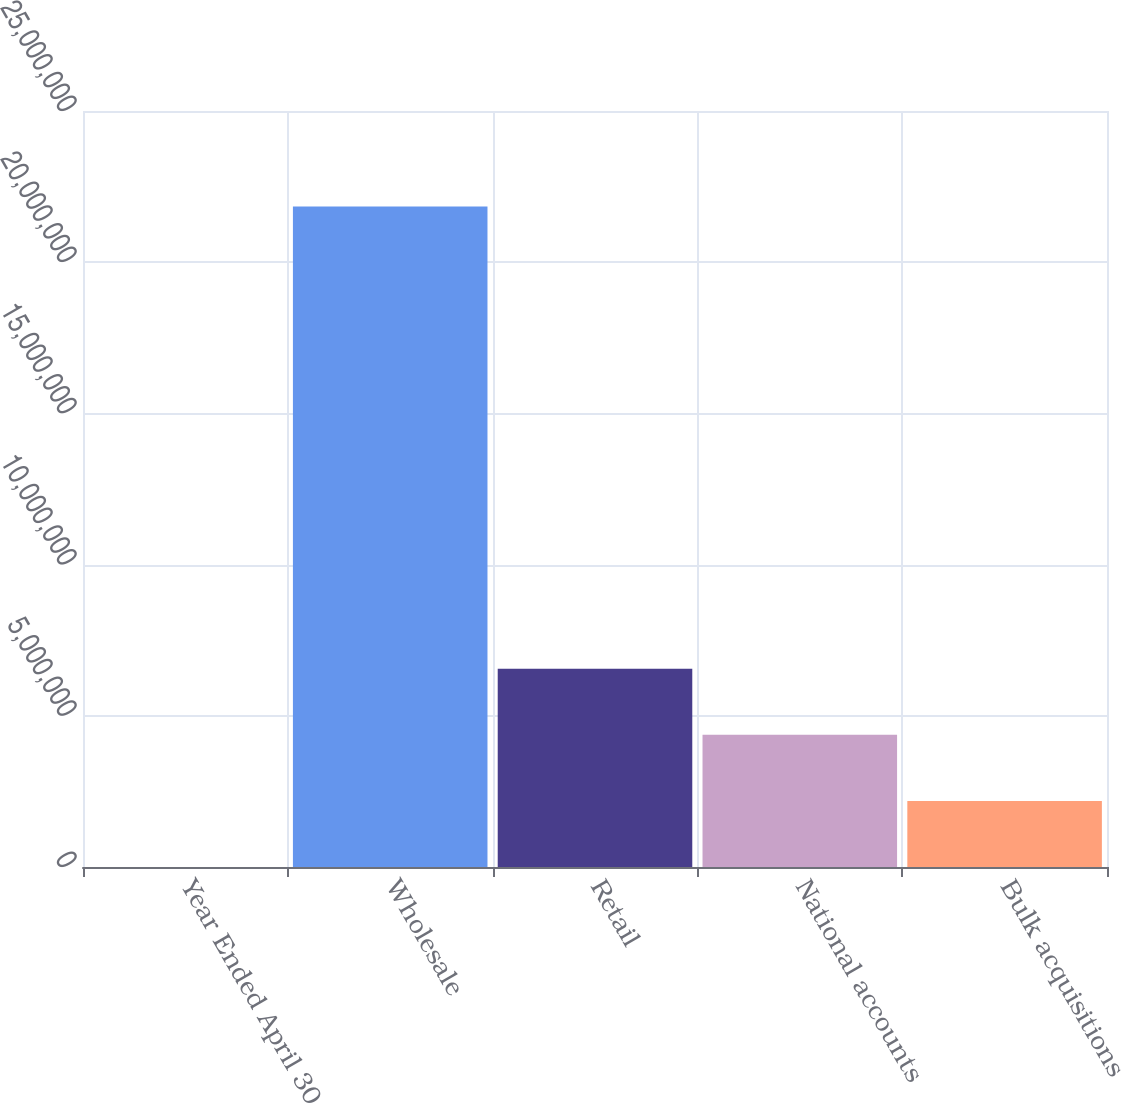<chart> <loc_0><loc_0><loc_500><loc_500><bar_chart><fcel>Year Ended April 30<fcel>Wholesale<fcel>Retail<fcel>National accounts<fcel>Bulk acquisitions<nl><fcel>2005<fcel>2.18418e+07<fcel>6.55394e+06<fcel>4.36996e+06<fcel>2.18598e+06<nl></chart> 